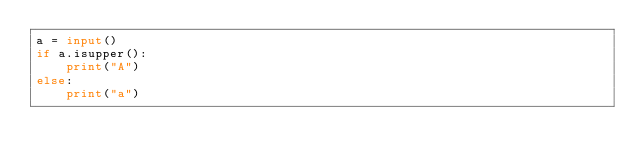Convert code to text. <code><loc_0><loc_0><loc_500><loc_500><_Python_>a = input()
if a.isupper():
    print("A")
else:
    print("a")</code> 